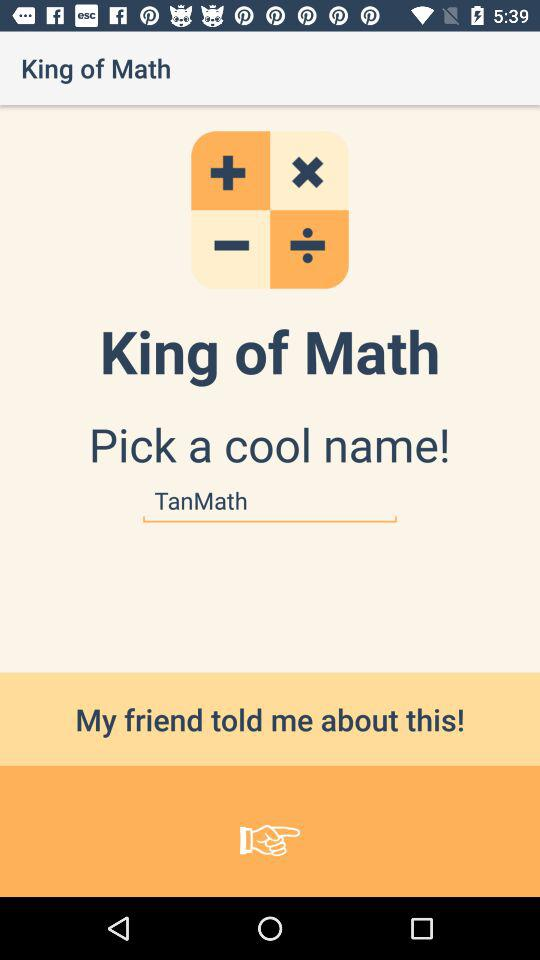What is the cool name chosen for the "King of Math"? The cool name chosen for the "King of Math" is "TanMath". 